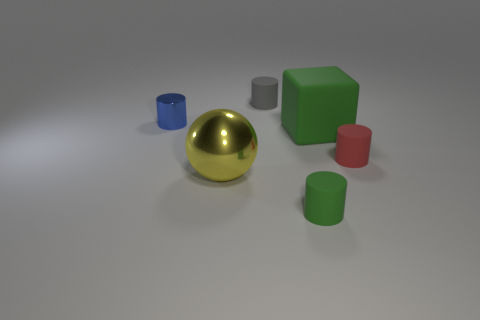Subtract all small green cylinders. How many cylinders are left? 3 Add 2 tiny blue metal cylinders. How many objects exist? 8 Subtract all gray cylinders. How many cylinders are left? 3 Subtract 2 cylinders. How many cylinders are left? 2 Subtract all cylinders. How many objects are left? 2 Subtract all blue cubes. How many green cylinders are left? 1 Subtract all large things. Subtract all large blue cubes. How many objects are left? 4 Add 5 small metallic objects. How many small metallic objects are left? 6 Add 5 small blue things. How many small blue things exist? 6 Subtract 0 brown balls. How many objects are left? 6 